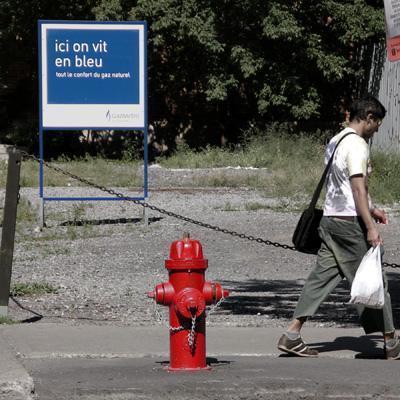How many guys are there?
Give a very brief answer. 1. How many bags is the man in the photograph carrying?
Give a very brief answer. 2. 